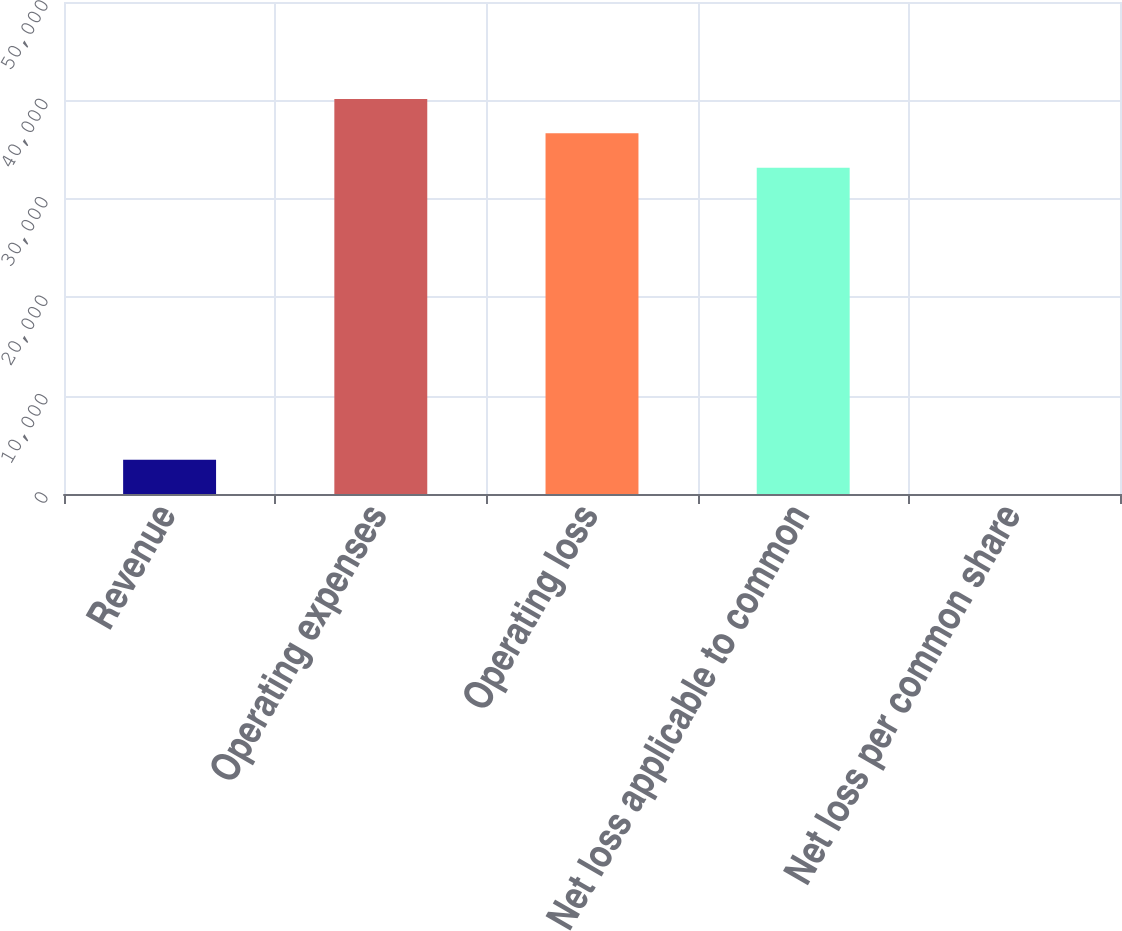Convert chart. <chart><loc_0><loc_0><loc_500><loc_500><bar_chart><fcel>Revenue<fcel>Operating expenses<fcel>Operating loss<fcel>Net loss applicable to common<fcel>Net loss per common share<nl><fcel>3489.35<fcel>40142.6<fcel>36654.3<fcel>33166<fcel>1.06<nl></chart> 